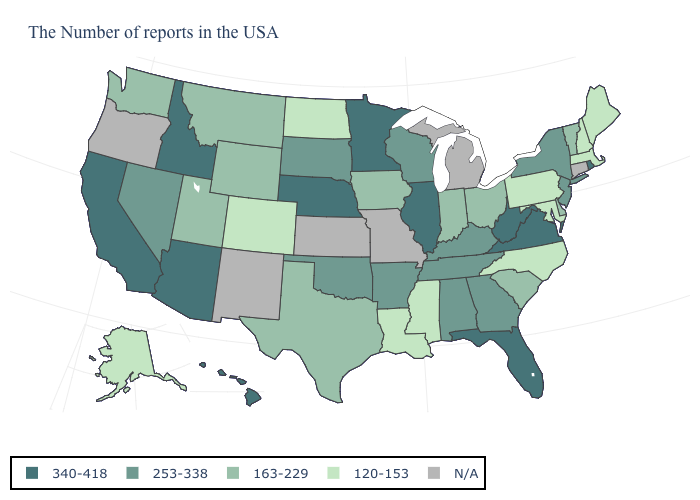What is the value of Kentucky?
Concise answer only. 253-338. Which states hav the highest value in the West?
Be succinct. Arizona, Idaho, California, Hawaii. What is the value of Maine?
Concise answer only. 120-153. What is the highest value in the USA?
Quick response, please. 340-418. Name the states that have a value in the range N/A?
Keep it brief. Connecticut, Michigan, Missouri, Kansas, New Mexico, Oregon. Name the states that have a value in the range N/A?
Be succinct. Connecticut, Michigan, Missouri, Kansas, New Mexico, Oregon. Does the map have missing data?
Be succinct. Yes. Among the states that border Arkansas , which have the highest value?
Concise answer only. Tennessee, Oklahoma. What is the value of Indiana?
Short answer required. 163-229. What is the lowest value in states that border Delaware?
Quick response, please. 120-153. Name the states that have a value in the range 340-418?
Be succinct. Rhode Island, Virginia, West Virginia, Florida, Illinois, Minnesota, Nebraska, Arizona, Idaho, California, Hawaii. Does Maine have the lowest value in the USA?
Quick response, please. Yes. Does South Carolina have the highest value in the USA?
Quick response, please. No. Which states have the highest value in the USA?
Concise answer only. Rhode Island, Virginia, West Virginia, Florida, Illinois, Minnesota, Nebraska, Arizona, Idaho, California, Hawaii. What is the lowest value in states that border Maryland?
Answer briefly. 120-153. 